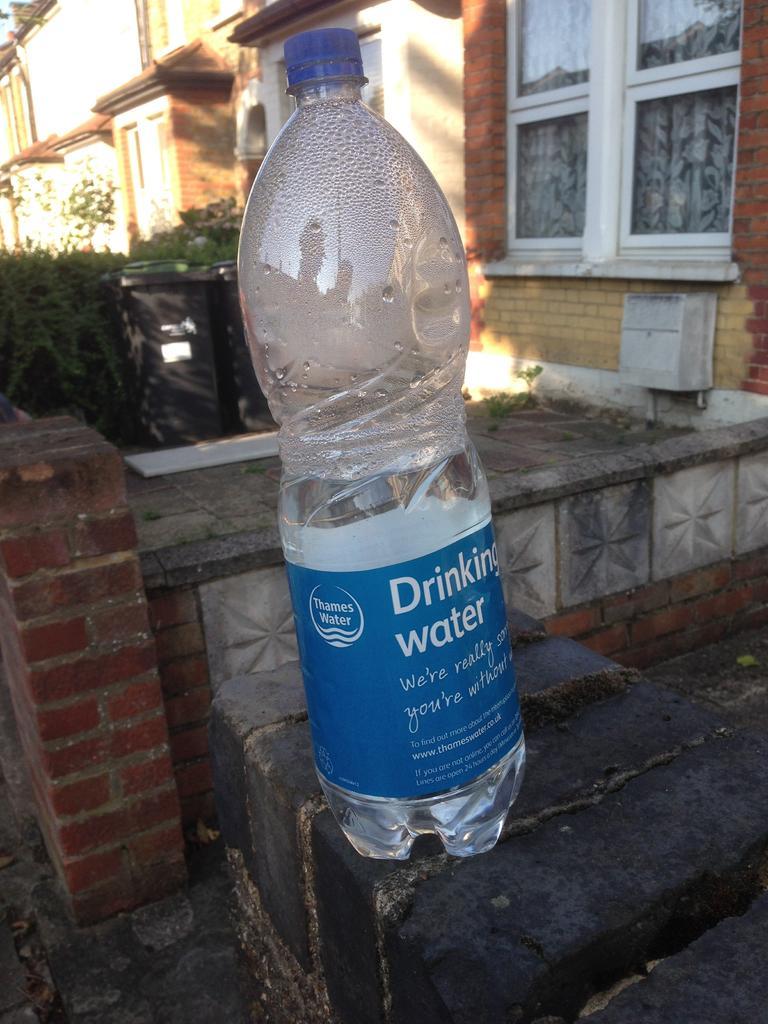Please provide a concise description of this image. A bottle is on the brick wall,behind it there is a building and plants. 